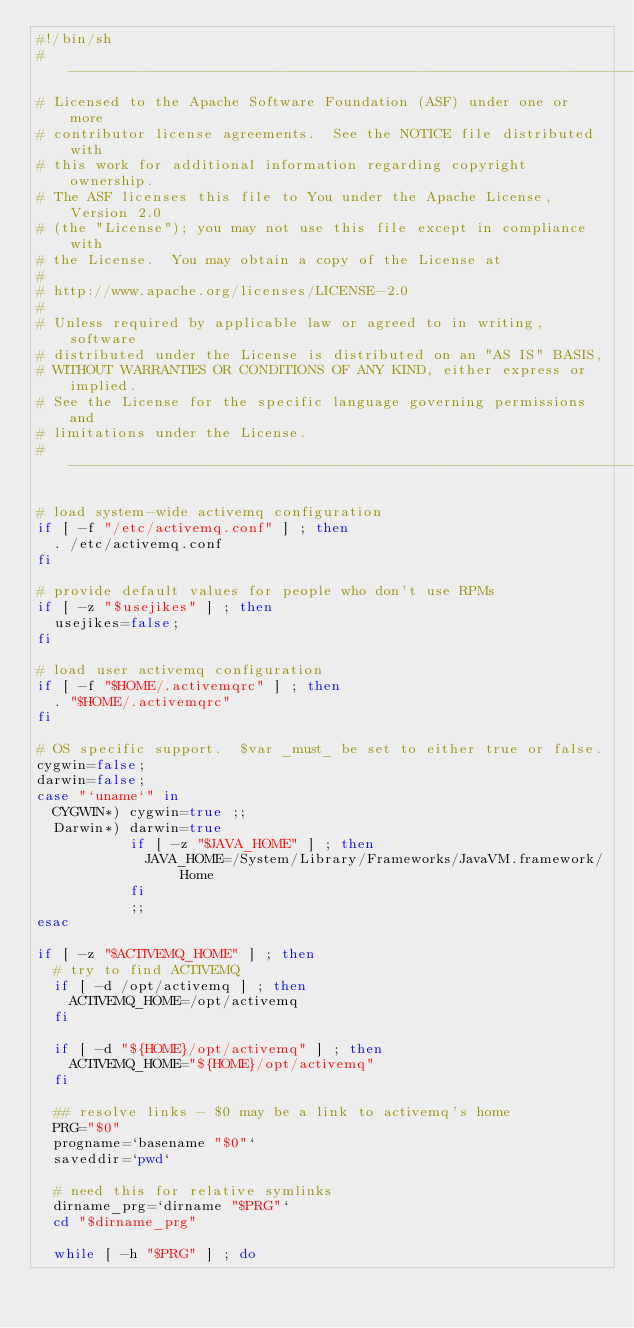<code> <loc_0><loc_0><loc_500><loc_500><_Bash_>#!/bin/sh
# ------------------------------------------------------------------------
# Licensed to the Apache Software Foundation (ASF) under one or more
# contributor license agreements.  See the NOTICE file distributed with
# this work for additional information regarding copyright ownership.
# The ASF licenses this file to You under the Apache License, Version 2.0
# (the "License"); you may not use this file except in compliance with
# the License.  You may obtain a copy of the License at
# 
# http://www.apache.org/licenses/LICENSE-2.0
# 
# Unless required by applicable law or agreed to in writing, software
# distributed under the License is distributed on an "AS IS" BASIS,
# WITHOUT WARRANTIES OR CONDITIONS OF ANY KIND, either express or implied.
# See the License for the specific language governing permissions and
# limitations under the License.
# ------------------------------------------------------------------------

# load system-wide activemq configuration
if [ -f "/etc/activemq.conf" ] ; then
  . /etc/activemq.conf
fi

# provide default values for people who don't use RPMs
if [ -z "$usejikes" ] ; then
  usejikes=false;
fi

# load user activemq configuration
if [ -f "$HOME/.activemqrc" ] ; then
  . "$HOME/.activemqrc"
fi

# OS specific support.  $var _must_ be set to either true or false.
cygwin=false;
darwin=false;
case "`uname`" in
  CYGWIN*) cygwin=true ;;
  Darwin*) darwin=true
           if [ -z "$JAVA_HOME" ] ; then
             JAVA_HOME=/System/Library/Frameworks/JavaVM.framework/Home
           fi
           ;;
esac

if [ -z "$ACTIVEMQ_HOME" ] ; then
  # try to find ACTIVEMQ
  if [ -d /opt/activemq ] ; then
    ACTIVEMQ_HOME=/opt/activemq
  fi

  if [ -d "${HOME}/opt/activemq" ] ; then
    ACTIVEMQ_HOME="${HOME}/opt/activemq"
  fi

  ## resolve links - $0 may be a link to activemq's home
  PRG="$0"
  progname=`basename "$0"`
  saveddir=`pwd`

  # need this for relative symlinks
  dirname_prg=`dirname "$PRG"`
  cd "$dirname_prg"

  while [ -h "$PRG" ] ; do</code> 